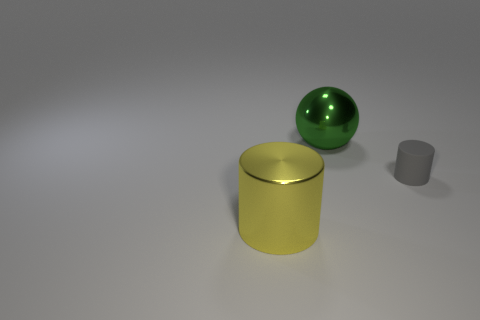Subtract all gray cylinders. How many cylinders are left? 1 Add 1 green things. How many objects exist? 4 Subtract 1 cylinders. How many cylinders are left? 1 Subtract all gray cubes. How many gray cylinders are left? 1 Add 1 yellow things. How many yellow things exist? 2 Subtract 0 blue cubes. How many objects are left? 3 Subtract all spheres. How many objects are left? 2 Subtract all yellow cylinders. Subtract all yellow balls. How many cylinders are left? 1 Subtract all tiny rubber things. Subtract all big yellow cylinders. How many objects are left? 1 Add 1 large yellow objects. How many large yellow objects are left? 2 